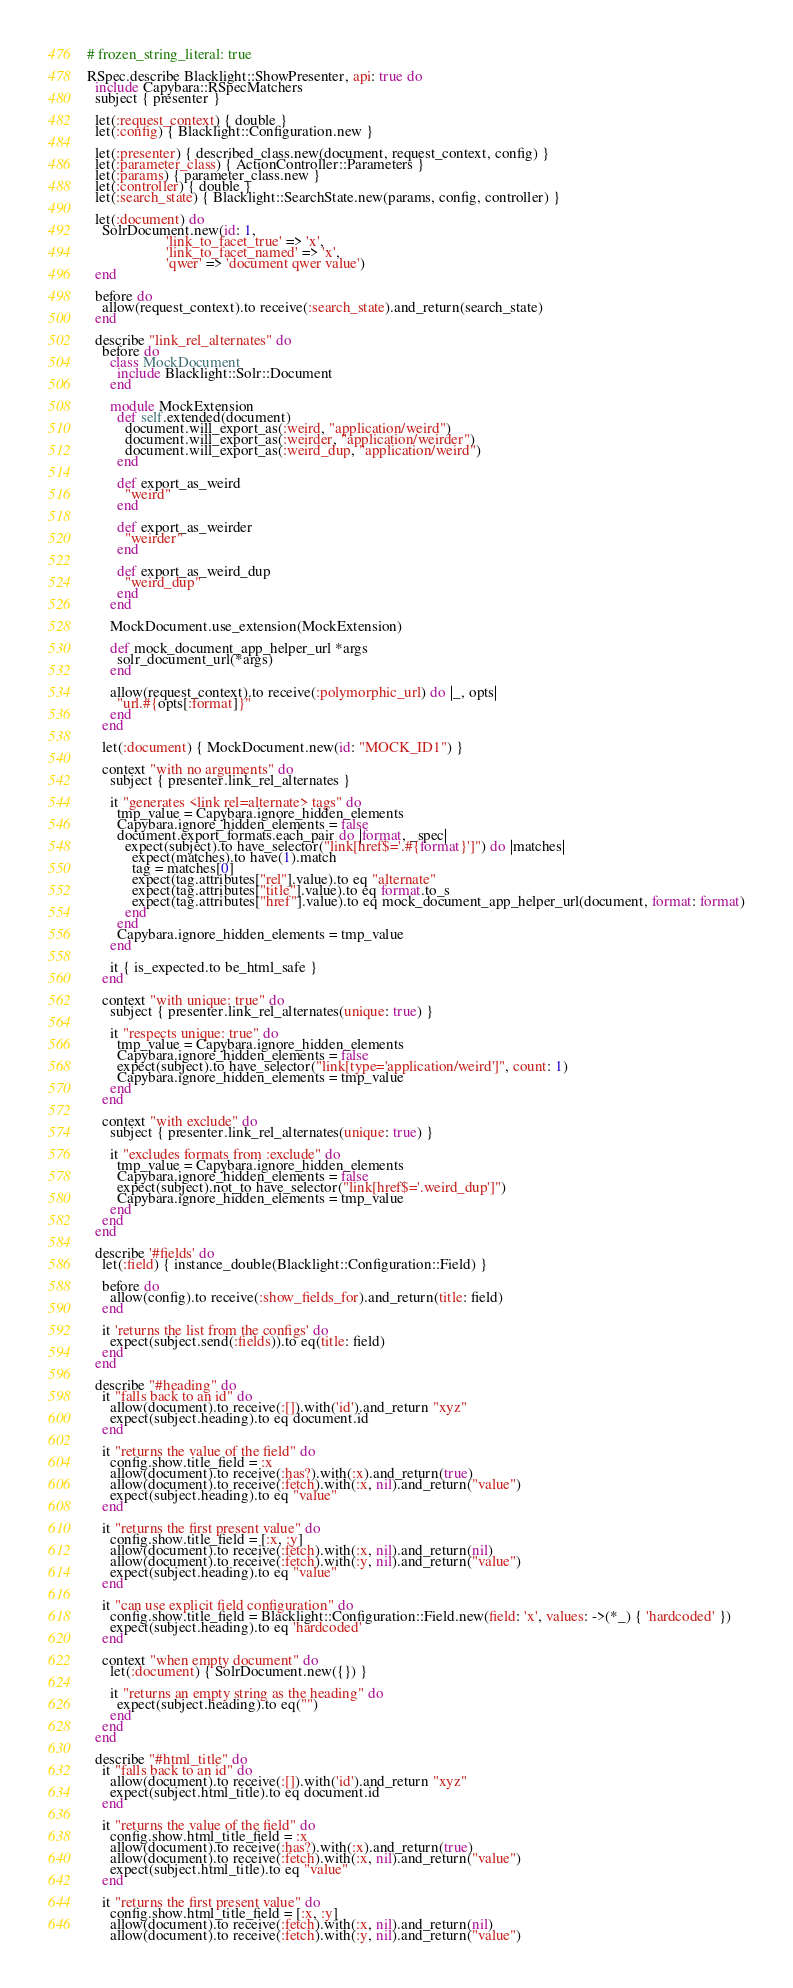Convert code to text. <code><loc_0><loc_0><loc_500><loc_500><_Ruby_># frozen_string_literal: true

RSpec.describe Blacklight::ShowPresenter, api: true do
  include Capybara::RSpecMatchers
  subject { presenter }

  let(:request_context) { double }
  let(:config) { Blacklight::Configuration.new }

  let(:presenter) { described_class.new(document, request_context, config) }
  let(:parameter_class) { ActionController::Parameters }
  let(:params) { parameter_class.new }
  let(:controller) { double }
  let(:search_state) { Blacklight::SearchState.new(params, config, controller) }

  let(:document) do
    SolrDocument.new(id: 1,
                     'link_to_facet_true' => 'x',
                     'link_to_facet_named' => 'x',
                     'qwer' => 'document qwer value')
  end

  before do
    allow(request_context).to receive(:search_state).and_return(search_state)
  end

  describe "link_rel_alternates" do
    before do
      class MockDocument
        include Blacklight::Solr::Document
      end

      module MockExtension
        def self.extended(document)
          document.will_export_as(:weird, "application/weird")
          document.will_export_as(:weirder, "application/weirder")
          document.will_export_as(:weird_dup, "application/weird")
        end

        def export_as_weird
          "weird"
        end

        def export_as_weirder
          "weirder"
        end

        def export_as_weird_dup
          "weird_dup"
        end
      end

      MockDocument.use_extension(MockExtension)

      def mock_document_app_helper_url *args
        solr_document_url(*args)
      end

      allow(request_context).to receive(:polymorphic_url) do |_, opts|
        "url.#{opts[:format]}"
      end
    end

    let(:document) { MockDocument.new(id: "MOCK_ID1") }

    context "with no arguments" do
      subject { presenter.link_rel_alternates }

      it "generates <link rel=alternate> tags" do
        tmp_value = Capybara.ignore_hidden_elements
        Capybara.ignore_hidden_elements = false
        document.export_formats.each_pair do |format, _spec|
          expect(subject).to have_selector("link[href$='.#{format}']") do |matches|
            expect(matches).to have(1).match
            tag = matches[0]
            expect(tag.attributes["rel"].value).to eq "alternate"
            expect(tag.attributes["title"].value).to eq format.to_s
            expect(tag.attributes["href"].value).to eq mock_document_app_helper_url(document, format: format)
          end
        end
        Capybara.ignore_hidden_elements = tmp_value
      end

      it { is_expected.to be_html_safe }
    end

    context "with unique: true" do
      subject { presenter.link_rel_alternates(unique: true) }

      it "respects unique: true" do
        tmp_value = Capybara.ignore_hidden_elements
        Capybara.ignore_hidden_elements = false
        expect(subject).to have_selector("link[type='application/weird']", count: 1)
        Capybara.ignore_hidden_elements = tmp_value
      end
    end

    context "with exclude" do
      subject { presenter.link_rel_alternates(unique: true) }

      it "excludes formats from :exclude" do
        tmp_value = Capybara.ignore_hidden_elements
        Capybara.ignore_hidden_elements = false
        expect(subject).not_to have_selector("link[href$='.weird_dup']")
        Capybara.ignore_hidden_elements = tmp_value
      end
    end
  end

  describe '#fields' do
    let(:field) { instance_double(Blacklight::Configuration::Field) }

    before do
      allow(config).to receive(:show_fields_for).and_return(title: field)
    end

    it 'returns the list from the configs' do
      expect(subject.send(:fields)).to eq(title: field)
    end
  end

  describe "#heading" do
    it "falls back to an id" do
      allow(document).to receive(:[]).with('id').and_return "xyz"
      expect(subject.heading).to eq document.id
    end

    it "returns the value of the field" do
      config.show.title_field = :x
      allow(document).to receive(:has?).with(:x).and_return(true)
      allow(document).to receive(:fetch).with(:x, nil).and_return("value")
      expect(subject.heading).to eq "value"
    end

    it "returns the first present value" do
      config.show.title_field = [:x, :y]
      allow(document).to receive(:fetch).with(:x, nil).and_return(nil)
      allow(document).to receive(:fetch).with(:y, nil).and_return("value")
      expect(subject.heading).to eq "value"
    end

    it "can use explicit field configuration" do
      config.show.title_field = Blacklight::Configuration::Field.new(field: 'x', values: ->(*_) { 'hardcoded' })
      expect(subject.heading).to eq 'hardcoded'
    end

    context "when empty document" do
      let(:document) { SolrDocument.new({}) }

      it "returns an empty string as the heading" do
        expect(subject.heading).to eq("")
      end
    end
  end

  describe "#html_title" do
    it "falls back to an id" do
      allow(document).to receive(:[]).with('id').and_return "xyz"
      expect(subject.html_title).to eq document.id
    end

    it "returns the value of the field" do
      config.show.html_title_field = :x
      allow(document).to receive(:has?).with(:x).and_return(true)
      allow(document).to receive(:fetch).with(:x, nil).and_return("value")
      expect(subject.html_title).to eq "value"
    end

    it "returns the first present value" do
      config.show.html_title_field = [:x, :y]
      allow(document).to receive(:fetch).with(:x, nil).and_return(nil)
      allow(document).to receive(:fetch).with(:y, nil).and_return("value")</code> 